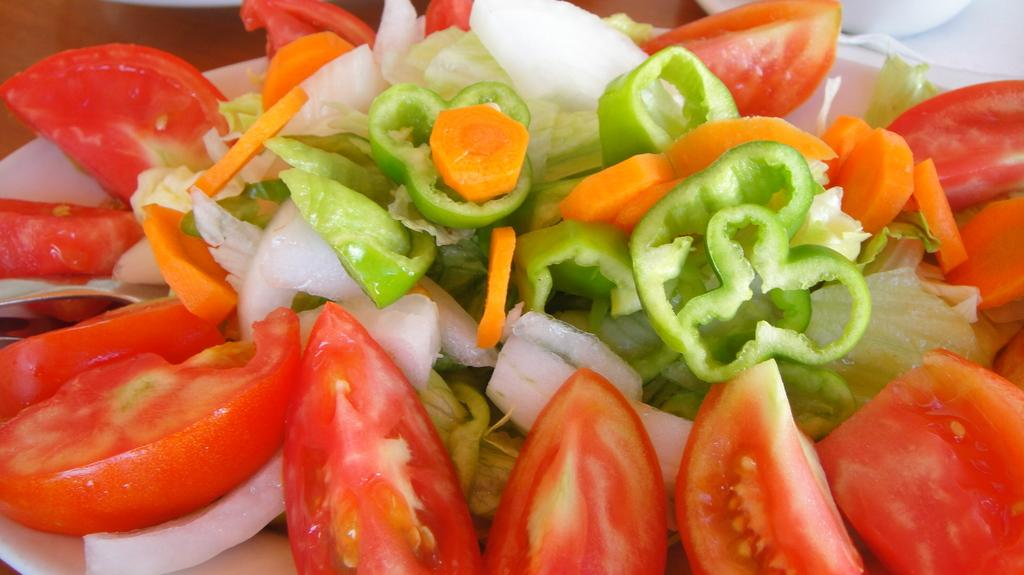What is the main subject of the image? The main subject of the image is a salad. What specific ingredients can be seen in the salad? The salad contains tomatoes and capsicum. Are there any other vegetables in the salad? Yes, the salad contains other vegetables besides tomatoes and capsicum. Can you see a receipt for the salad in the image? No, there is no receipt present in the image. What type of stamp is visible on the capsicum in the image? There is no stamp on the capsicum or any other ingredient in the image. 